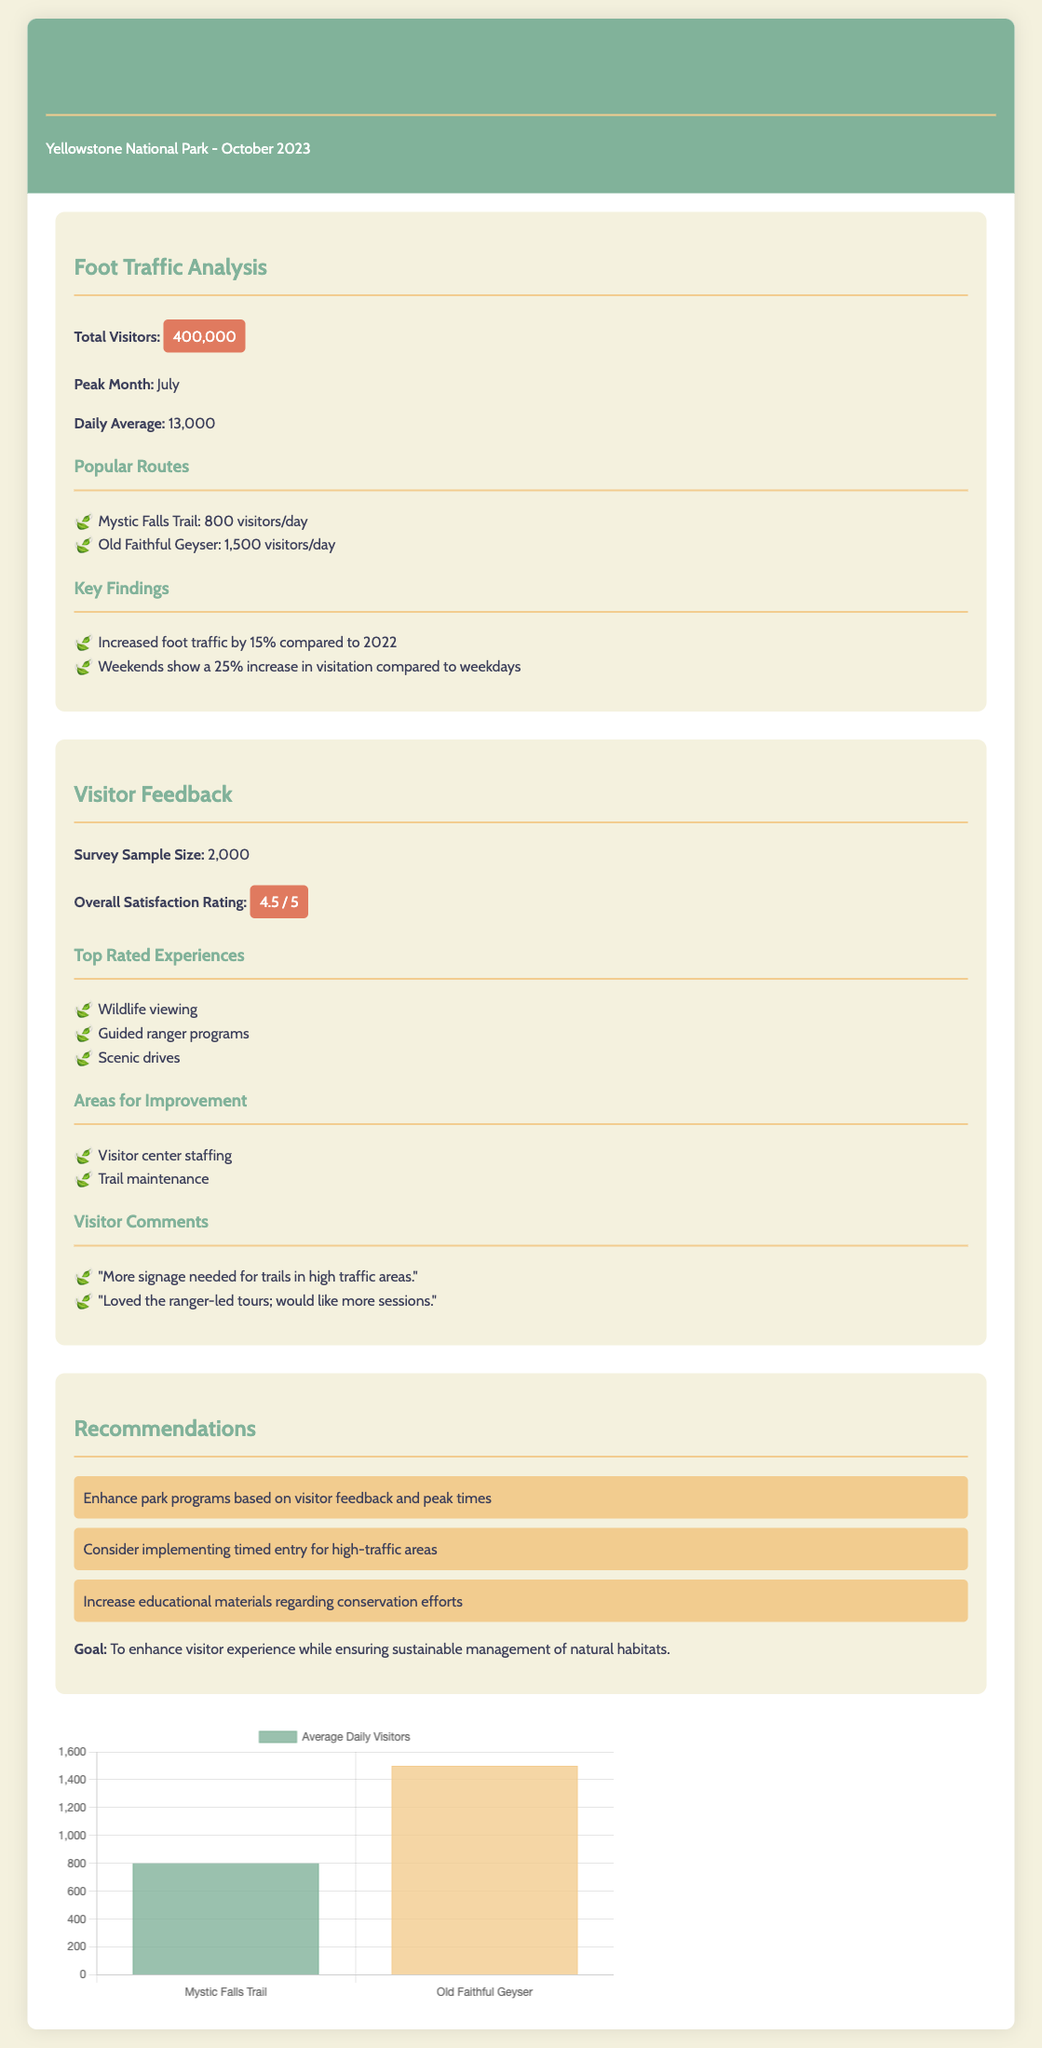What was the total number of visitors in October 2023? The total number of visitors is directly stated in the report as 400,000.
Answer: 400,000 What is the peak month for visitor traffic? The report indicates that the peak month is July.
Answer: July What is the daily average of visitors? The daily average of visitors is mentioned as 13,000.
Answer: 13,000 What was the overall satisfaction rating from the visitor surveys? The overall satisfaction rating is highlighted in the document as 4.5 out of 5.
Answer: 4.5 / 5 Which trail had the highest average daily visitors? The trail with the highest average daily visitors is Old Faithful Geyser, with 1,500 visitors per day.
Answer: Old Faithful Geyser What is one area identified for improvement in the visitor feedback? The visitor feedback section specifies visitor center staffing as an area for improvement.
Answer: Visitor center staffing How much did foot traffic increase compared to 2022? The report indicates that foot traffic increased by 15% compared to the previous year.
Answer: 15% What recommendation was made regarding high-traffic areas? The document recommends considering implementing timed entry for high-traffic areas.
Answer: Timed entry What was the sample size for the visitor surveys? The survey sample size is provided in the document as 2,000.
Answer: 2,000 